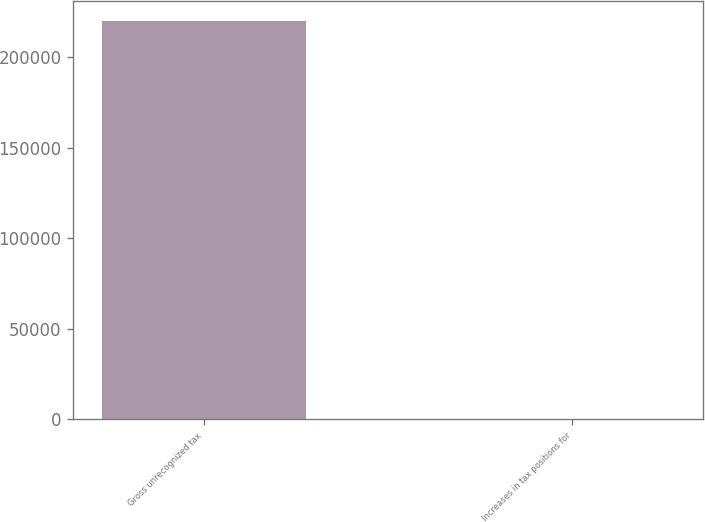Convert chart. <chart><loc_0><loc_0><loc_500><loc_500><bar_chart><fcel>Gross unrecognized tax<fcel>Increases in tax positions for<nl><fcel>219908<fcel>181<nl></chart> 